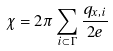Convert formula to latex. <formula><loc_0><loc_0><loc_500><loc_500>\chi = 2 \pi \sum _ { i \subset \Gamma } \frac { q _ { x , i } } { 2 e }</formula> 